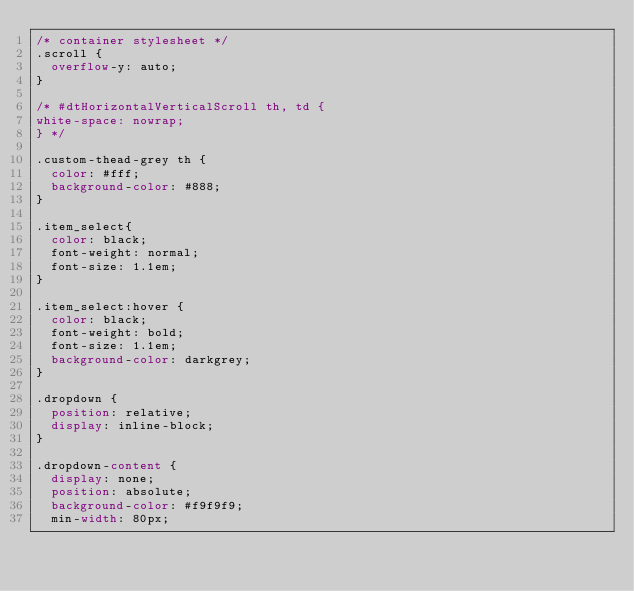Convert code to text. <code><loc_0><loc_0><loc_500><loc_500><_CSS_>/* container stylesheet */
.scroll {
  overflow-y: auto;
}

/* #dtHorizontalVerticalScroll th, td {
white-space: nowrap;
} */

.custom-thead-grey th {
  color: #fff;
  background-color: #888;
}

.item_select{
  color: black;
  font-weight: normal;
  font-size: 1.1em;
}

.item_select:hover {
  color: black;
  font-weight: bold;
  font-size: 1.1em;
  background-color: darkgrey;
}

.dropdown {
  position: relative;
  display: inline-block;
}

.dropdown-content {
  display: none;
  position: absolute;
  background-color: #f9f9f9;
  min-width: 80px;</code> 